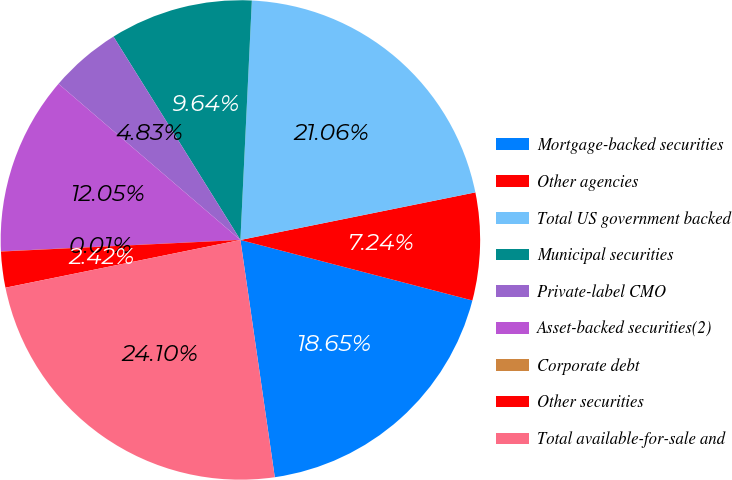Convert chart to OTSL. <chart><loc_0><loc_0><loc_500><loc_500><pie_chart><fcel>Mortgage-backed securities<fcel>Other agencies<fcel>Total US government backed<fcel>Municipal securities<fcel>Private-label CMO<fcel>Asset-backed securities(2)<fcel>Corporate debt<fcel>Other securities<fcel>Total available-for-sale and<nl><fcel>18.65%<fcel>7.24%<fcel>21.06%<fcel>9.64%<fcel>4.83%<fcel>12.05%<fcel>0.01%<fcel>2.42%<fcel>24.1%<nl></chart> 